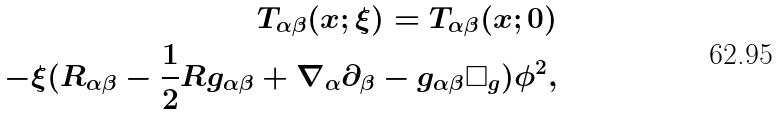Convert formula to latex. <formula><loc_0><loc_0><loc_500><loc_500>T _ { \alpha \beta } ( x ; \xi ) = T _ { \alpha \beta } ( x ; 0 ) \\ - \xi ( R _ { \alpha \beta } - \frac { 1 } { 2 } R g _ { \alpha \beta } + \nabla _ { \alpha } \partial _ { \beta } - g _ { \alpha \beta } \Box _ { g } ) \phi ^ { 2 } ,</formula> 